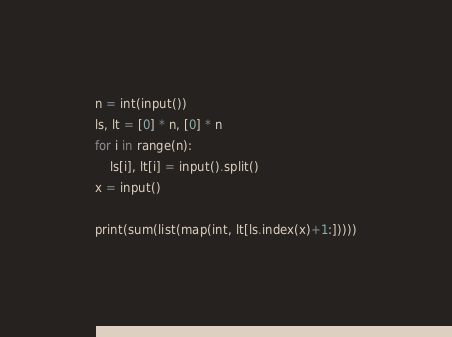Convert code to text. <code><loc_0><loc_0><loc_500><loc_500><_Python_>n = int(input())
ls, lt = [0] * n, [0] * n
for i in range(n):
    ls[i], lt[i] = input().split()
x = input()

print(sum(list(map(int, lt[ls.index(x)+1:]))))</code> 